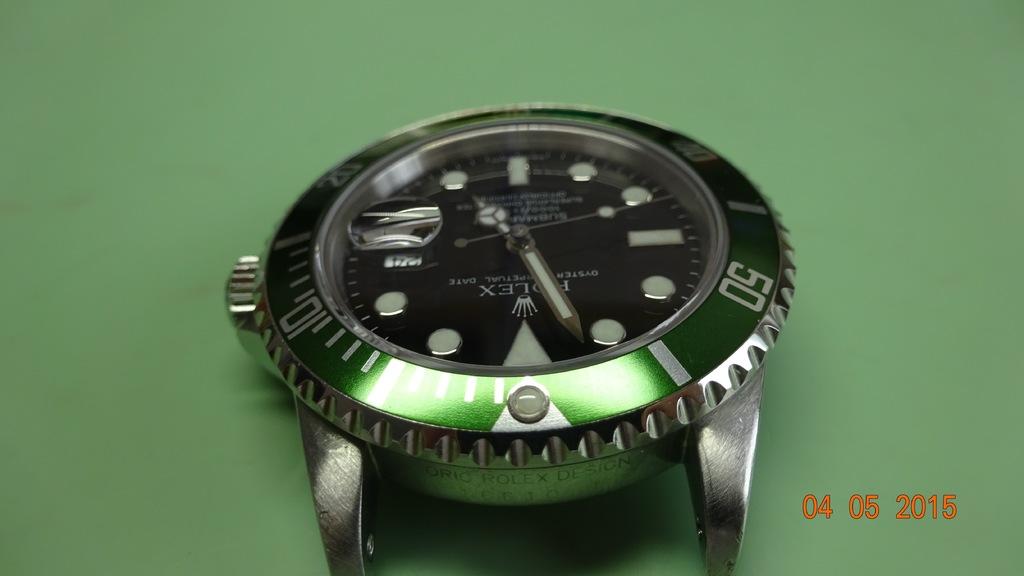What brand is the watch?
Your answer should be very brief. Rolex. 